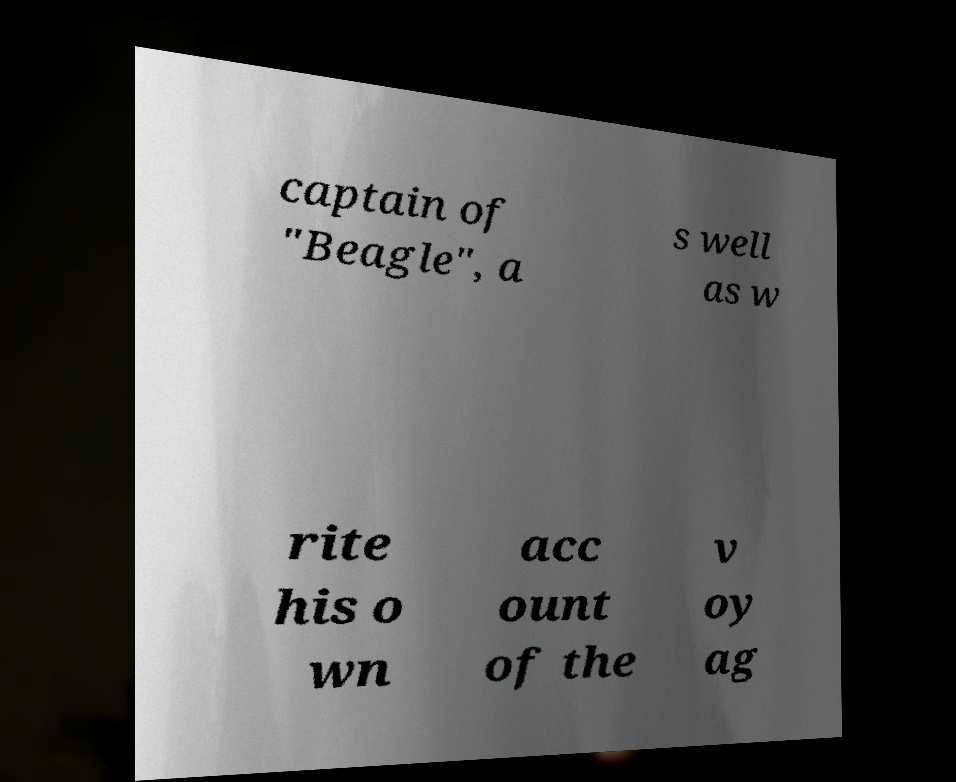There's text embedded in this image that I need extracted. Can you transcribe it verbatim? captain of "Beagle", a s well as w rite his o wn acc ount of the v oy ag 